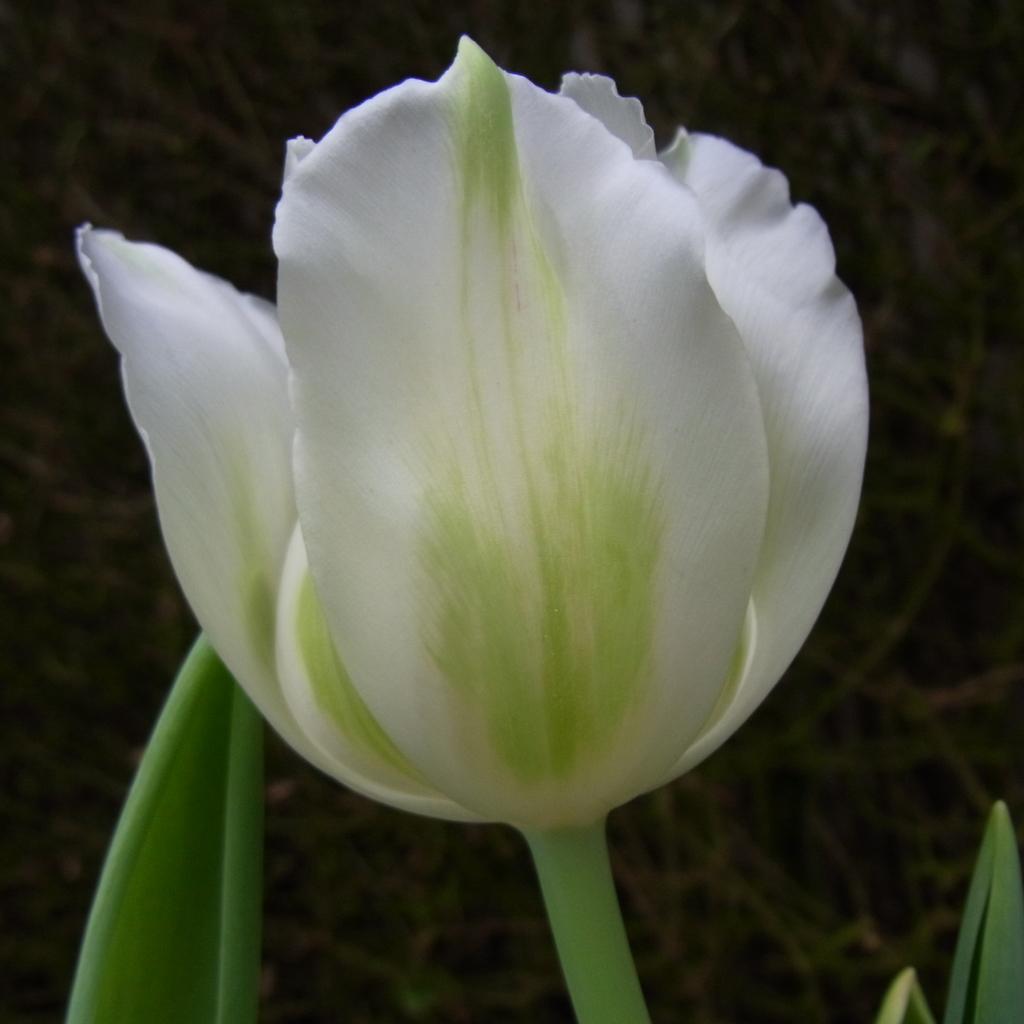Could you give a brief overview of what you see in this image? We can see flower, stem and leaves. In the background it is blur. 